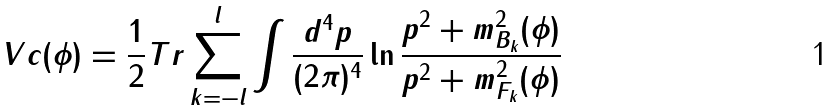<formula> <loc_0><loc_0><loc_500><loc_500>\ V c ( \phi ) = \frac { 1 } { 2 } T r \sum _ { k = - l } ^ { l } \int \frac { d ^ { 4 } p } { ( 2 \pi ) ^ { 4 } } \ln \frac { p ^ { 2 } + m _ { B _ { k } } ^ { 2 } ( \phi ) } { p ^ { 2 } + m _ { F _ { k } } ^ { 2 } ( \phi ) }</formula> 